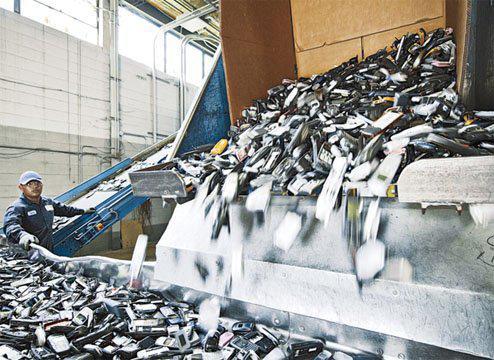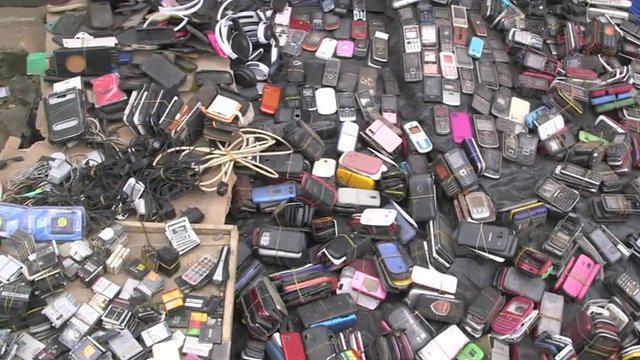The first image is the image on the left, the second image is the image on the right. For the images shown, is this caption "There are cell phone being pushed off a metal shelve to land on a conveyor belt." true? Answer yes or no. Yes. The first image is the image on the left, the second image is the image on the right. Examine the images to the left and right. Is the description "There is exactly one person in the left image." accurate? Answer yes or no. Yes. 